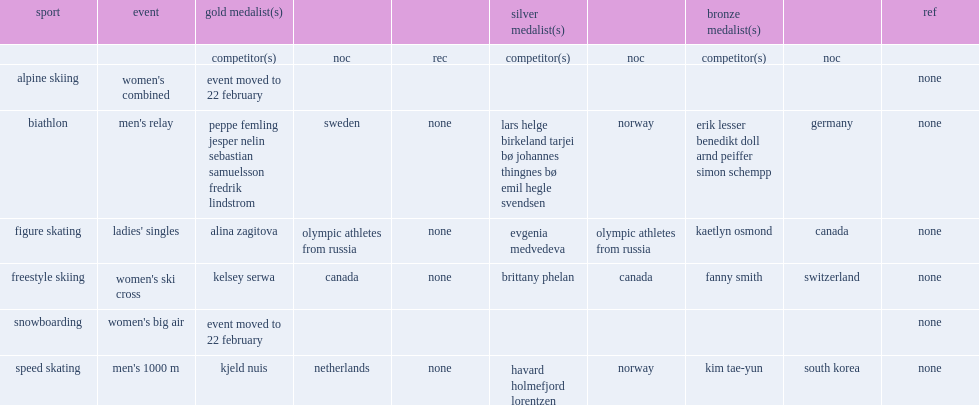Who was the gold medalist in the women's ski cross? Kelsey serwa. Parse the full table. {'header': ['sport', 'event', 'gold medalist(s)', '', '', 'silver medalist(s)', '', 'bronze medalist(s)', '', 'ref'], 'rows': [['', '', 'competitor(s)', 'noc', 'rec', 'competitor(s)', 'noc', 'competitor(s)', 'noc', ''], ['alpine skiing', "women's combined", 'event moved to 22 february', '', '', '', '', '', '', 'none'], ['biathlon', "men's relay", 'peppe femling jesper nelin sebastian samuelsson fredrik lindstrom', 'sweden', 'none', 'lars helge birkeland tarjei bø johannes thingnes bø emil hegle svendsen', 'norway', 'erik lesser benedikt doll arnd peiffer simon schempp', 'germany', 'none'], ['figure skating', "ladies' singles", 'alina zagitova', 'olympic athletes from russia', 'none', 'evgenia medvedeva', 'olympic athletes from russia', 'kaetlyn osmond', 'canada', 'none'], ['freestyle skiing', "women's ski cross", 'kelsey serwa', 'canada', 'none', 'brittany phelan', 'canada', 'fanny smith', 'switzerland', 'none'], ['snowboarding', "women's big air", 'event moved to 22 february', '', '', '', '', '', '', 'none'], ['speed skating', "men's 1000 m", 'kjeld nuis', 'netherlands', 'none', 'havard holmefjord lorentzen', 'norway', 'kim tae-yun', 'south korea', 'none']]} 